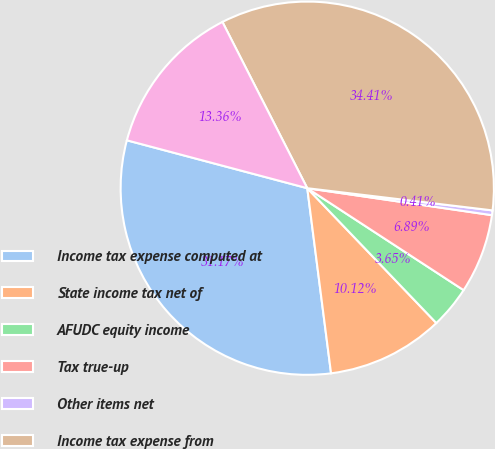Convert chart. <chart><loc_0><loc_0><loc_500><loc_500><pie_chart><fcel>Income tax expense computed at<fcel>State income tax net of<fcel>AFUDC equity income<fcel>Tax true-up<fcel>Other items net<fcel>Income tax expense from<fcel>Effective tax rate<nl><fcel>31.17%<fcel>10.12%<fcel>3.65%<fcel>6.89%<fcel>0.41%<fcel>34.41%<fcel>13.36%<nl></chart> 